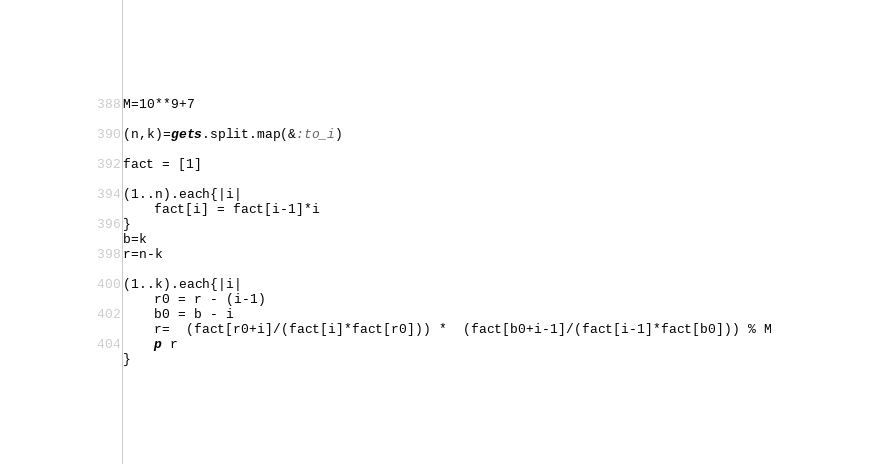<code> <loc_0><loc_0><loc_500><loc_500><_Ruby_>M=10**9+7

(n,k)=gets.split.map(&:to_i)

fact = [1]

(1..n).each{|i|
    fact[i] = fact[i-1]*i
}
b=k
r=n-k

(1..k).each{|i|
    r0 = r - (i-1)
    b0 = b - i
    r=  (fact[r0+i]/(fact[i]*fact[r0])) *  (fact[b0+i-1]/(fact[i-1]*fact[b0])) % M
    p r
}</code> 